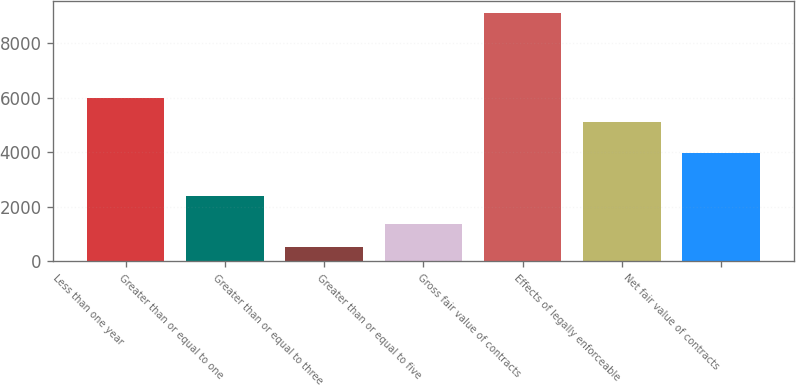Convert chart. <chart><loc_0><loc_0><loc_500><loc_500><bar_chart><fcel>Less than one year<fcel>Greater than or equal to one<fcel>Greater than or equal to three<fcel>Greater than or equal to five<fcel>Gross fair value of contracts<fcel>Effects of legally enforceable<fcel>Net fair value of contracts<nl><fcel>5966.8<fcel>2383<fcel>519<fcel>1375.8<fcel>9087<fcel>5110<fcel>3977<nl></chart> 